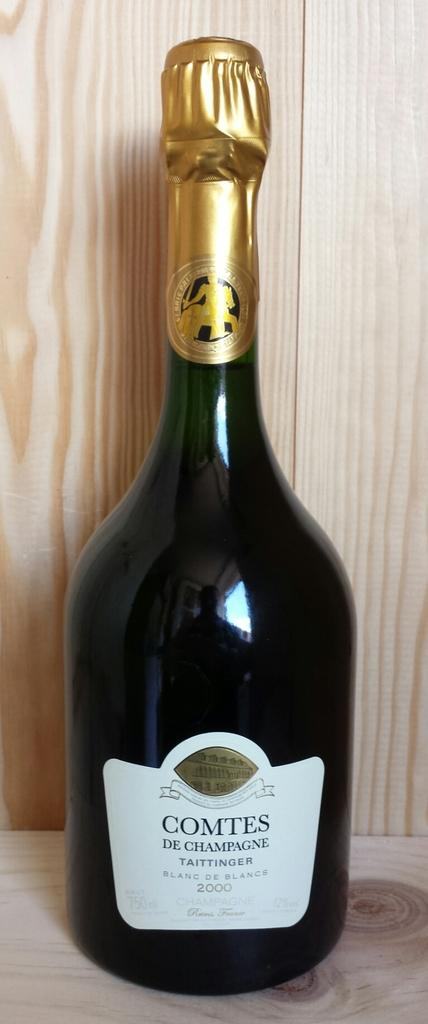<image>
Offer a succinct explanation of the picture presented. A bottle of champagne named Comtes De Champagne 